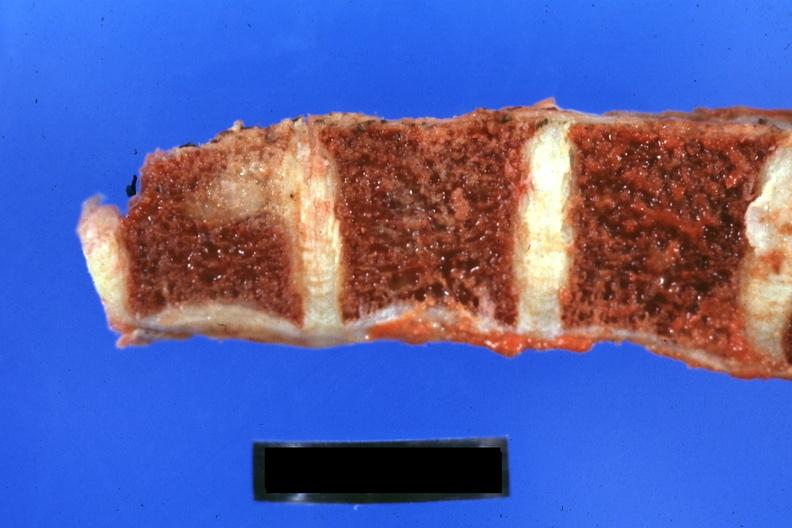when is obvious metastatic lesion 44yobfadenocarcinoma of lung giant cell type occurring 25 years?
Answer the question using a single word or phrase. Obvious 